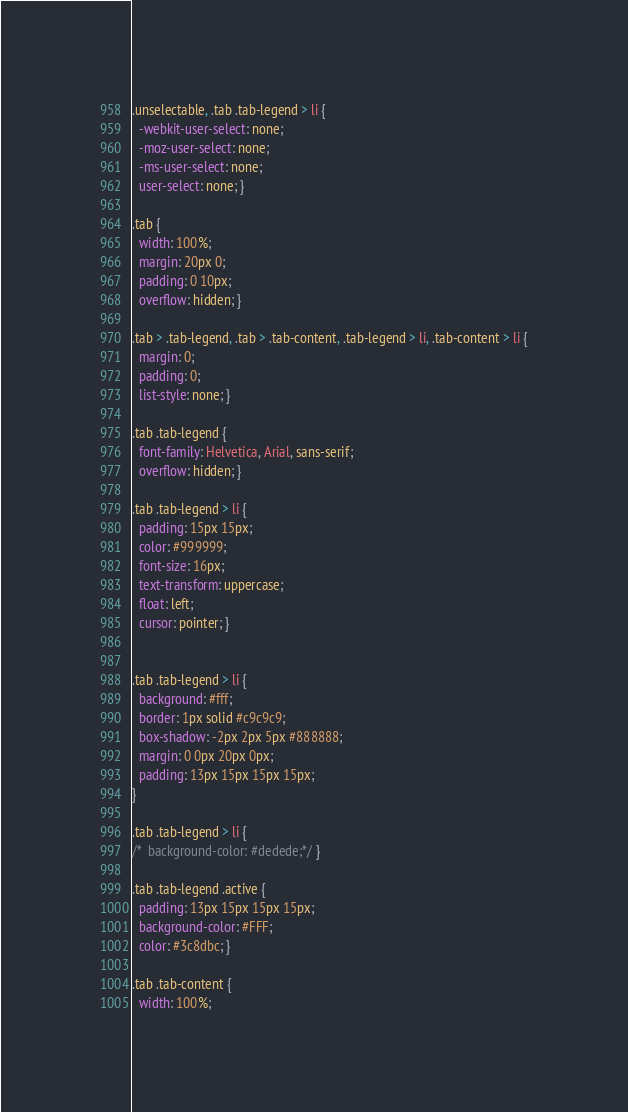<code> <loc_0><loc_0><loc_500><loc_500><_CSS_>.unselectable, .tab .tab-legend > li {
  -webkit-user-select: none;
  -moz-user-select: none;
  -ms-user-select: none;
  user-select: none; }

.tab {
  width: 100%;
  margin: 20px 0;
  padding: 0 10px;
  overflow: hidden; }

.tab > .tab-legend, .tab > .tab-content, .tab-legend > li, .tab-content > li {
  margin: 0;
  padding: 0;
  list-style: none; }

.tab .tab-legend {
  font-family: Helvetica, Arial, sans-serif;
  overflow: hidden; }

.tab .tab-legend > li {
  padding: 15px 15px;
  color: #999999;
  font-size: 16px;
  text-transform: uppercase;
  float: left;
  cursor: pointer; }


.tab .tab-legend > li {
  background: #fff;
  border: 1px solid #c9c9c9;
  box-shadow: -2px 2px 5px #888888;
  margin: 0 0px 20px 0px;
  padding: 13px 15px 15px 15px;
}

.tab .tab-legend > li {
/*  background-color: #dedede;*/ }

.tab .tab-legend .active {
  padding: 13px 15px 15px 15px;
  background-color: #FFF;
  color: #3c8dbc; }

.tab .tab-content {
  width: 100%;</code> 